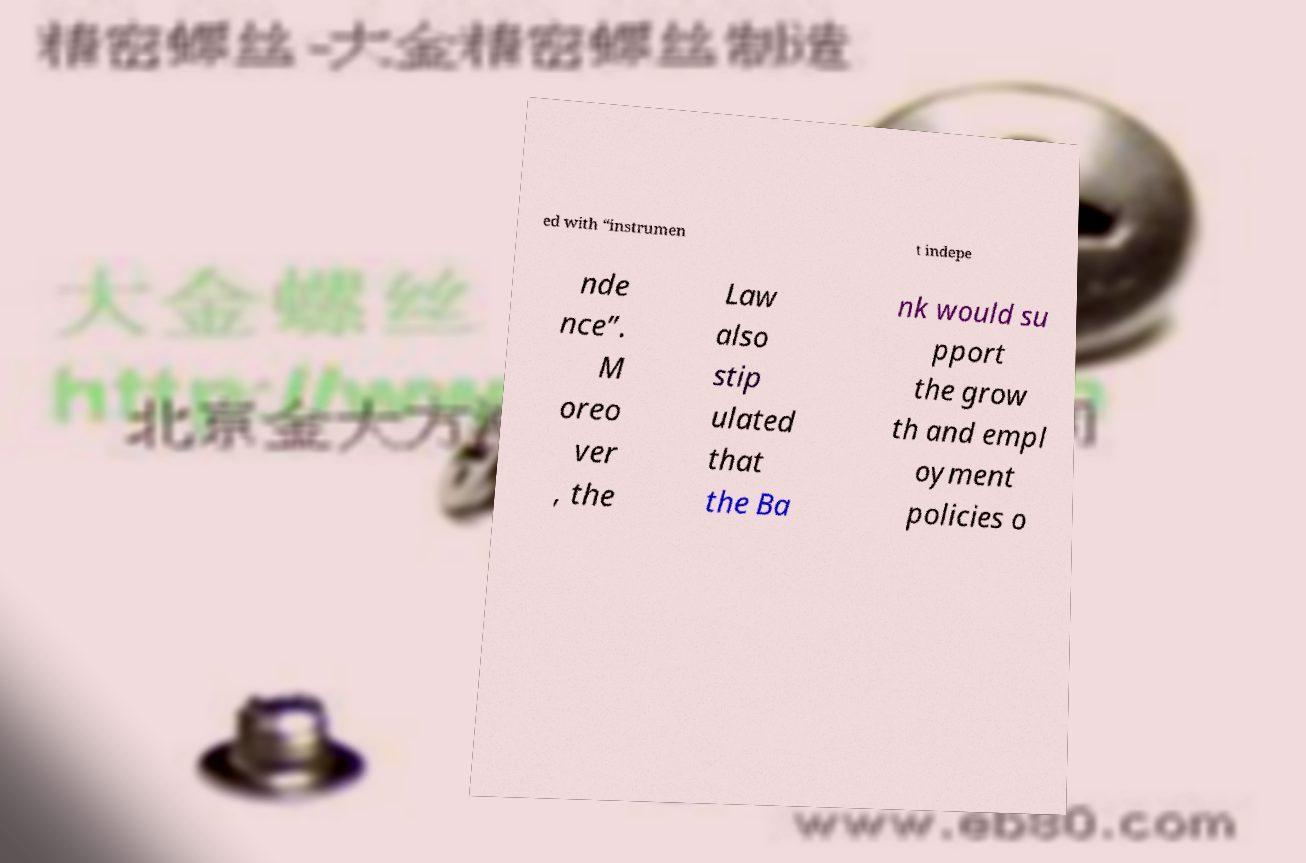Could you extract and type out the text from this image? ed with “instrumen t indepe nde nce”. M oreo ver , the Law also stip ulated that the Ba nk would su pport the grow th and empl oyment policies o 